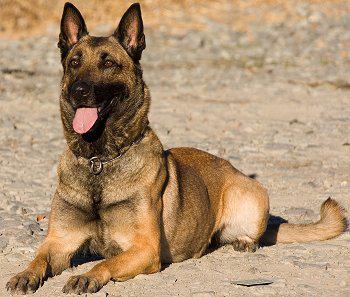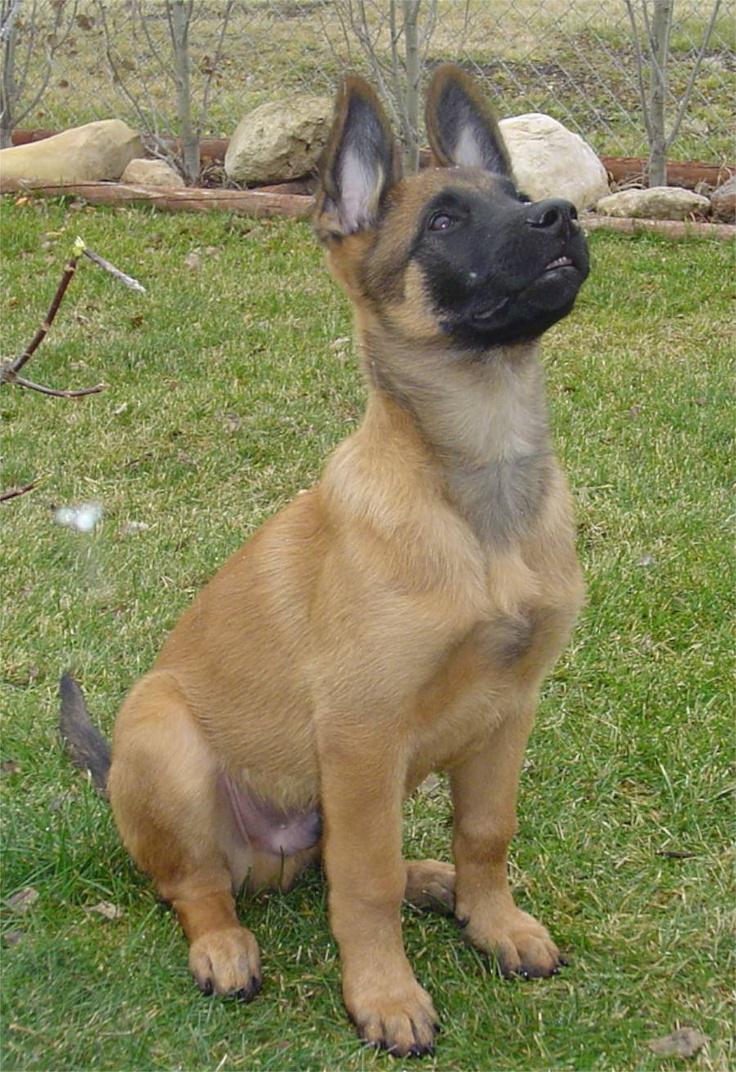The first image is the image on the left, the second image is the image on the right. For the images shown, is this caption "The dogs are looking in the same direction" true? Answer yes or no. No. The first image is the image on the left, the second image is the image on the right. Assess this claim about the two images: "There are exactly two German Shepherd dogs and either they both have collars around their neck or neither do.". Correct or not? Answer yes or no. No. 